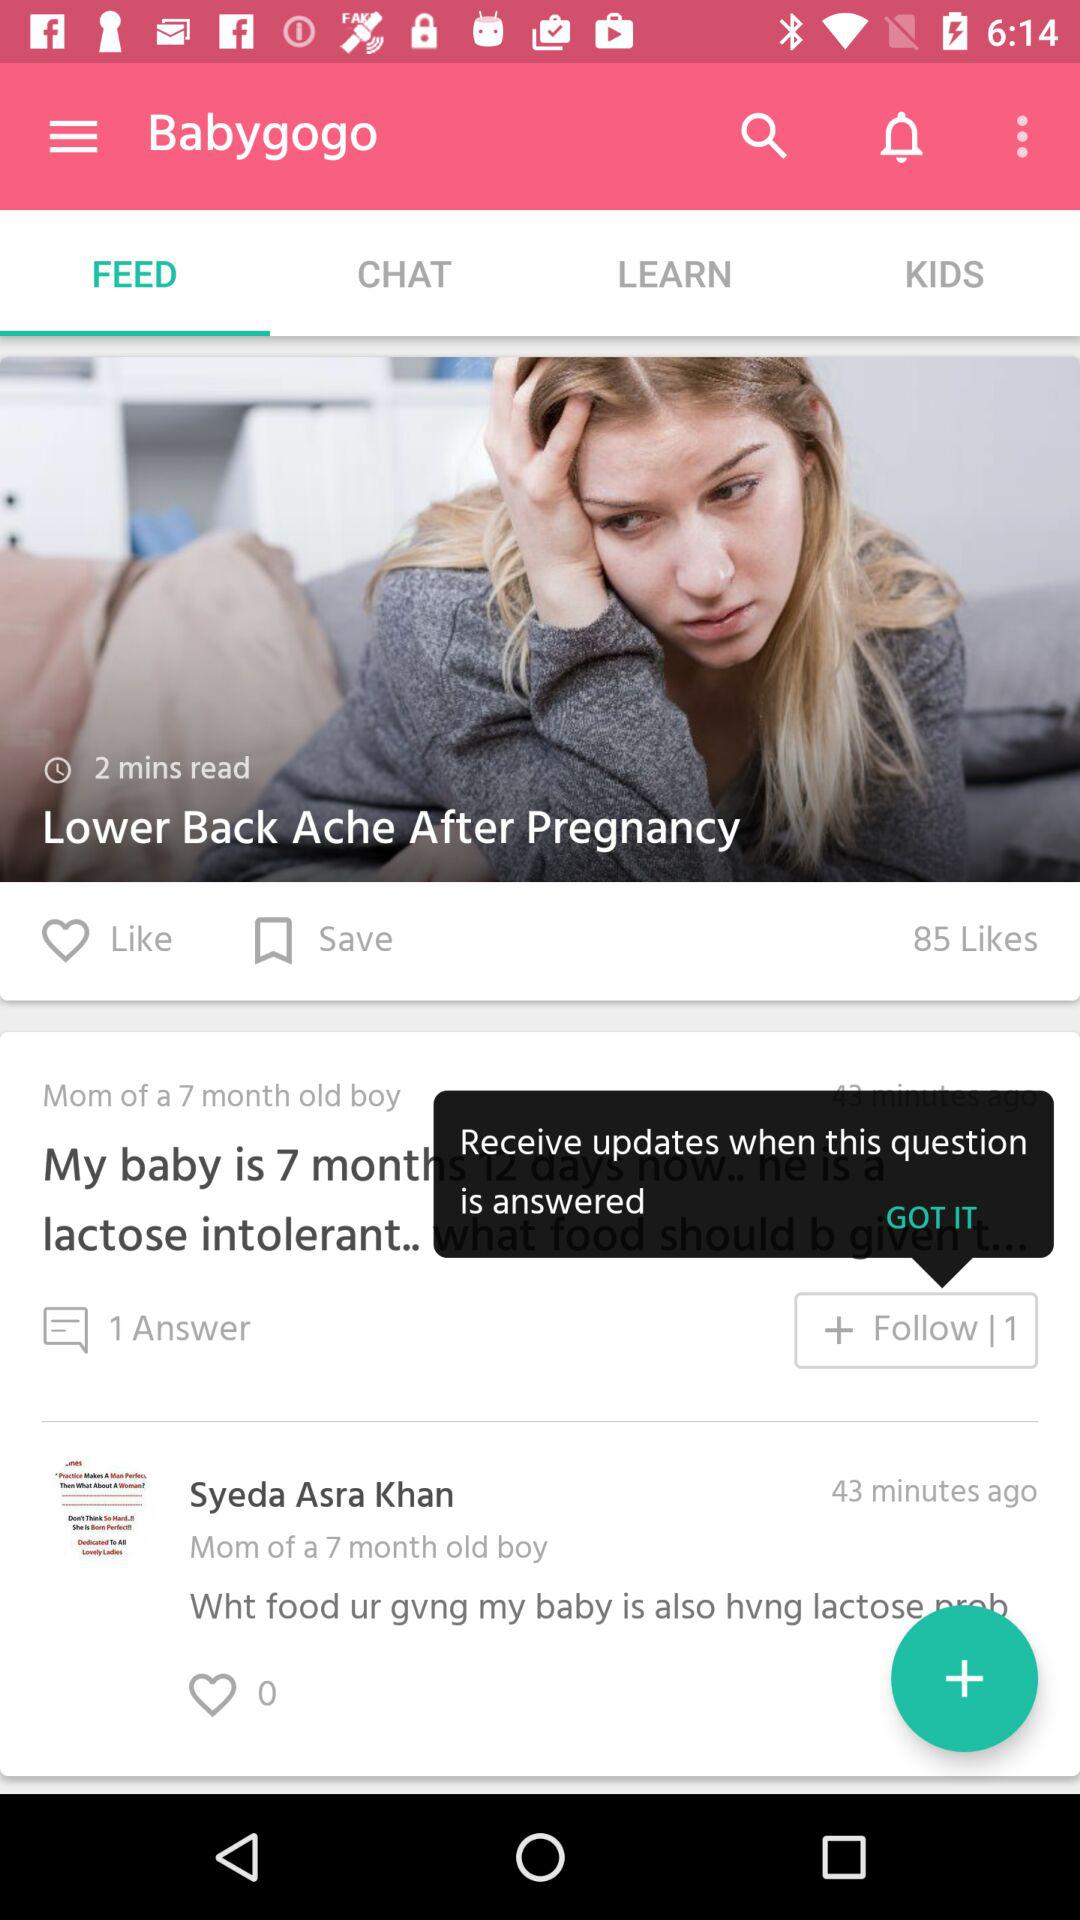How many followers are there?
When the provided information is insufficient, respond with <no answer>. <no answer> 